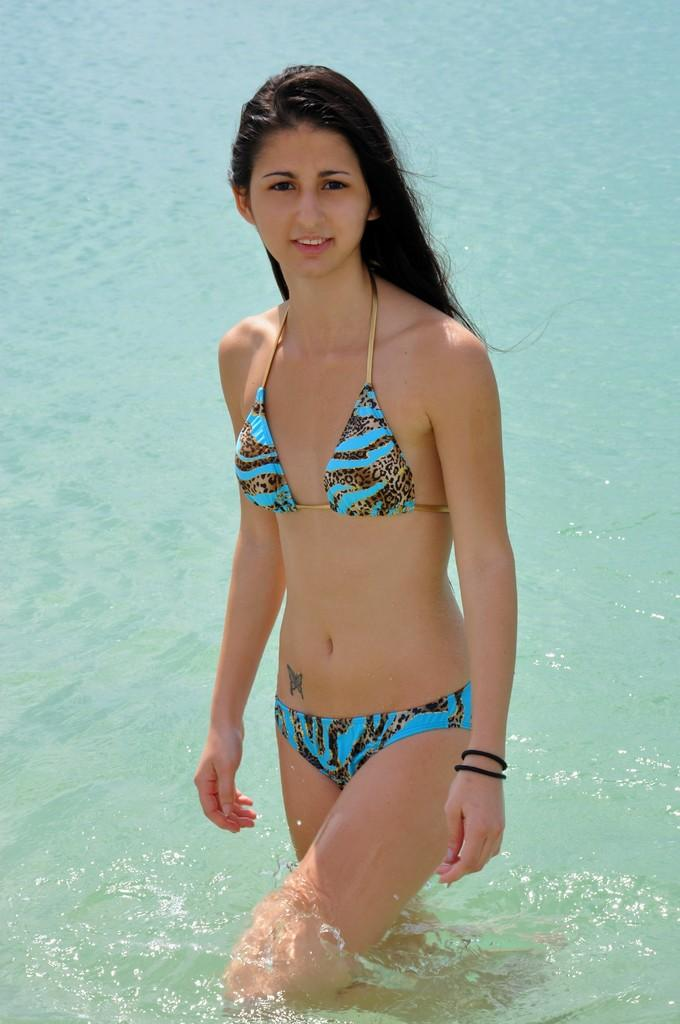Who is present in the image? There is a woman in the image. What can be seen in the background of the image? Water is visible in the image. What type of paste is the woman using in the image? There is no paste present in the image. Can you tell me the date on the receipt in the image? There is no receipt present in the image. 